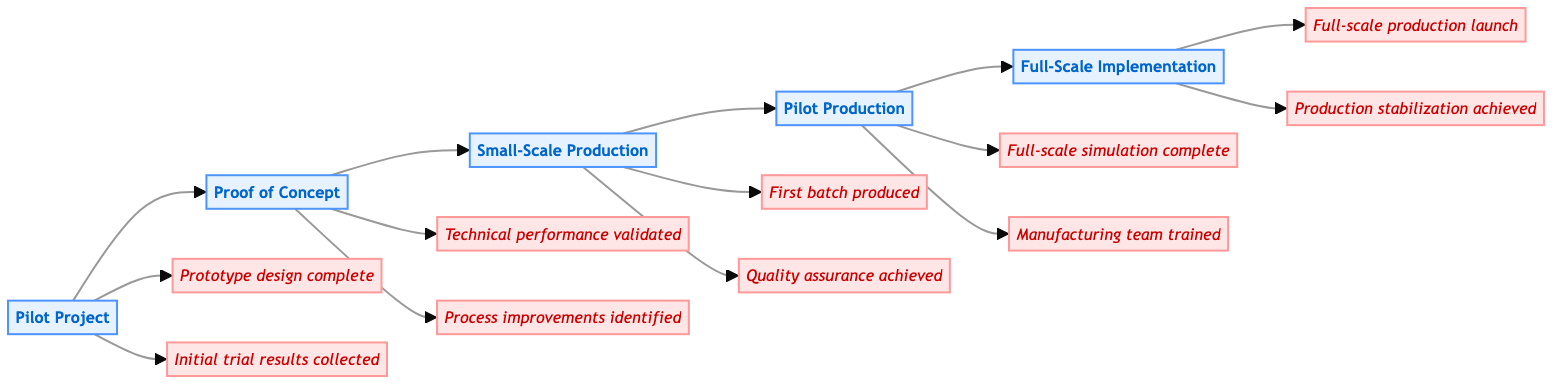What stage comes after Pilot Project? The diagram shows a flow from one stage to the next. After the Pilot Project stage, the next stage is labeled Proof of Concept.
Answer: Proof of Concept How many milestones are in the Full-Scale Implementation stage? The Full-Scale Implementation stage indicates two milestones connected to it: "Full-scale production launch" and "Production stabilization achieved." Therefore, there are two milestones in this stage.
Answer: 2 What is the primary objective of the Pilot Project? Within the Pilot Project stage, one of the listed objectives is to "Test feasibility." This indicates the main focus at this stage.
Answer: Test feasibility What activities are involved in Small-Scale Production? The Small-Scale Production stage outlines specific key activities such as "Setup small-scale manufacturing line," "Monitor production metrics," and "Implement quality control measures." Each plays a role in achieving the stage's goals.
Answer: Setup small-scale manufacturing line, Monitor production metrics, Implement quality control measures What milestone corresponds with the Proof of Concept stage? The Proof of Concept stage has two milestones: "Technical performance validated" and "Process improvements identified." Since the question asks for one, we can note the first one as a key milestone.
Answer: Technical performance validated What is the last stage in the clinical pathway? The pathway shows a clear end point with the flowchart connecting to the Full-Scale Implementation stage as the final step.
Answer: Full-Scale Implementation How many total stages are there in the diagram? By counting the individual stages listed in the diagram, there are five stages from Pilot Project through to Full-Scale Implementation.
Answer: 5 What is a key activity in the Pilot Production stage? The Pilot Production stage includes several key activities, one of which is "Deploy pilot production line," indicating a critical step in the process.
Answer: Deploy pilot production line 